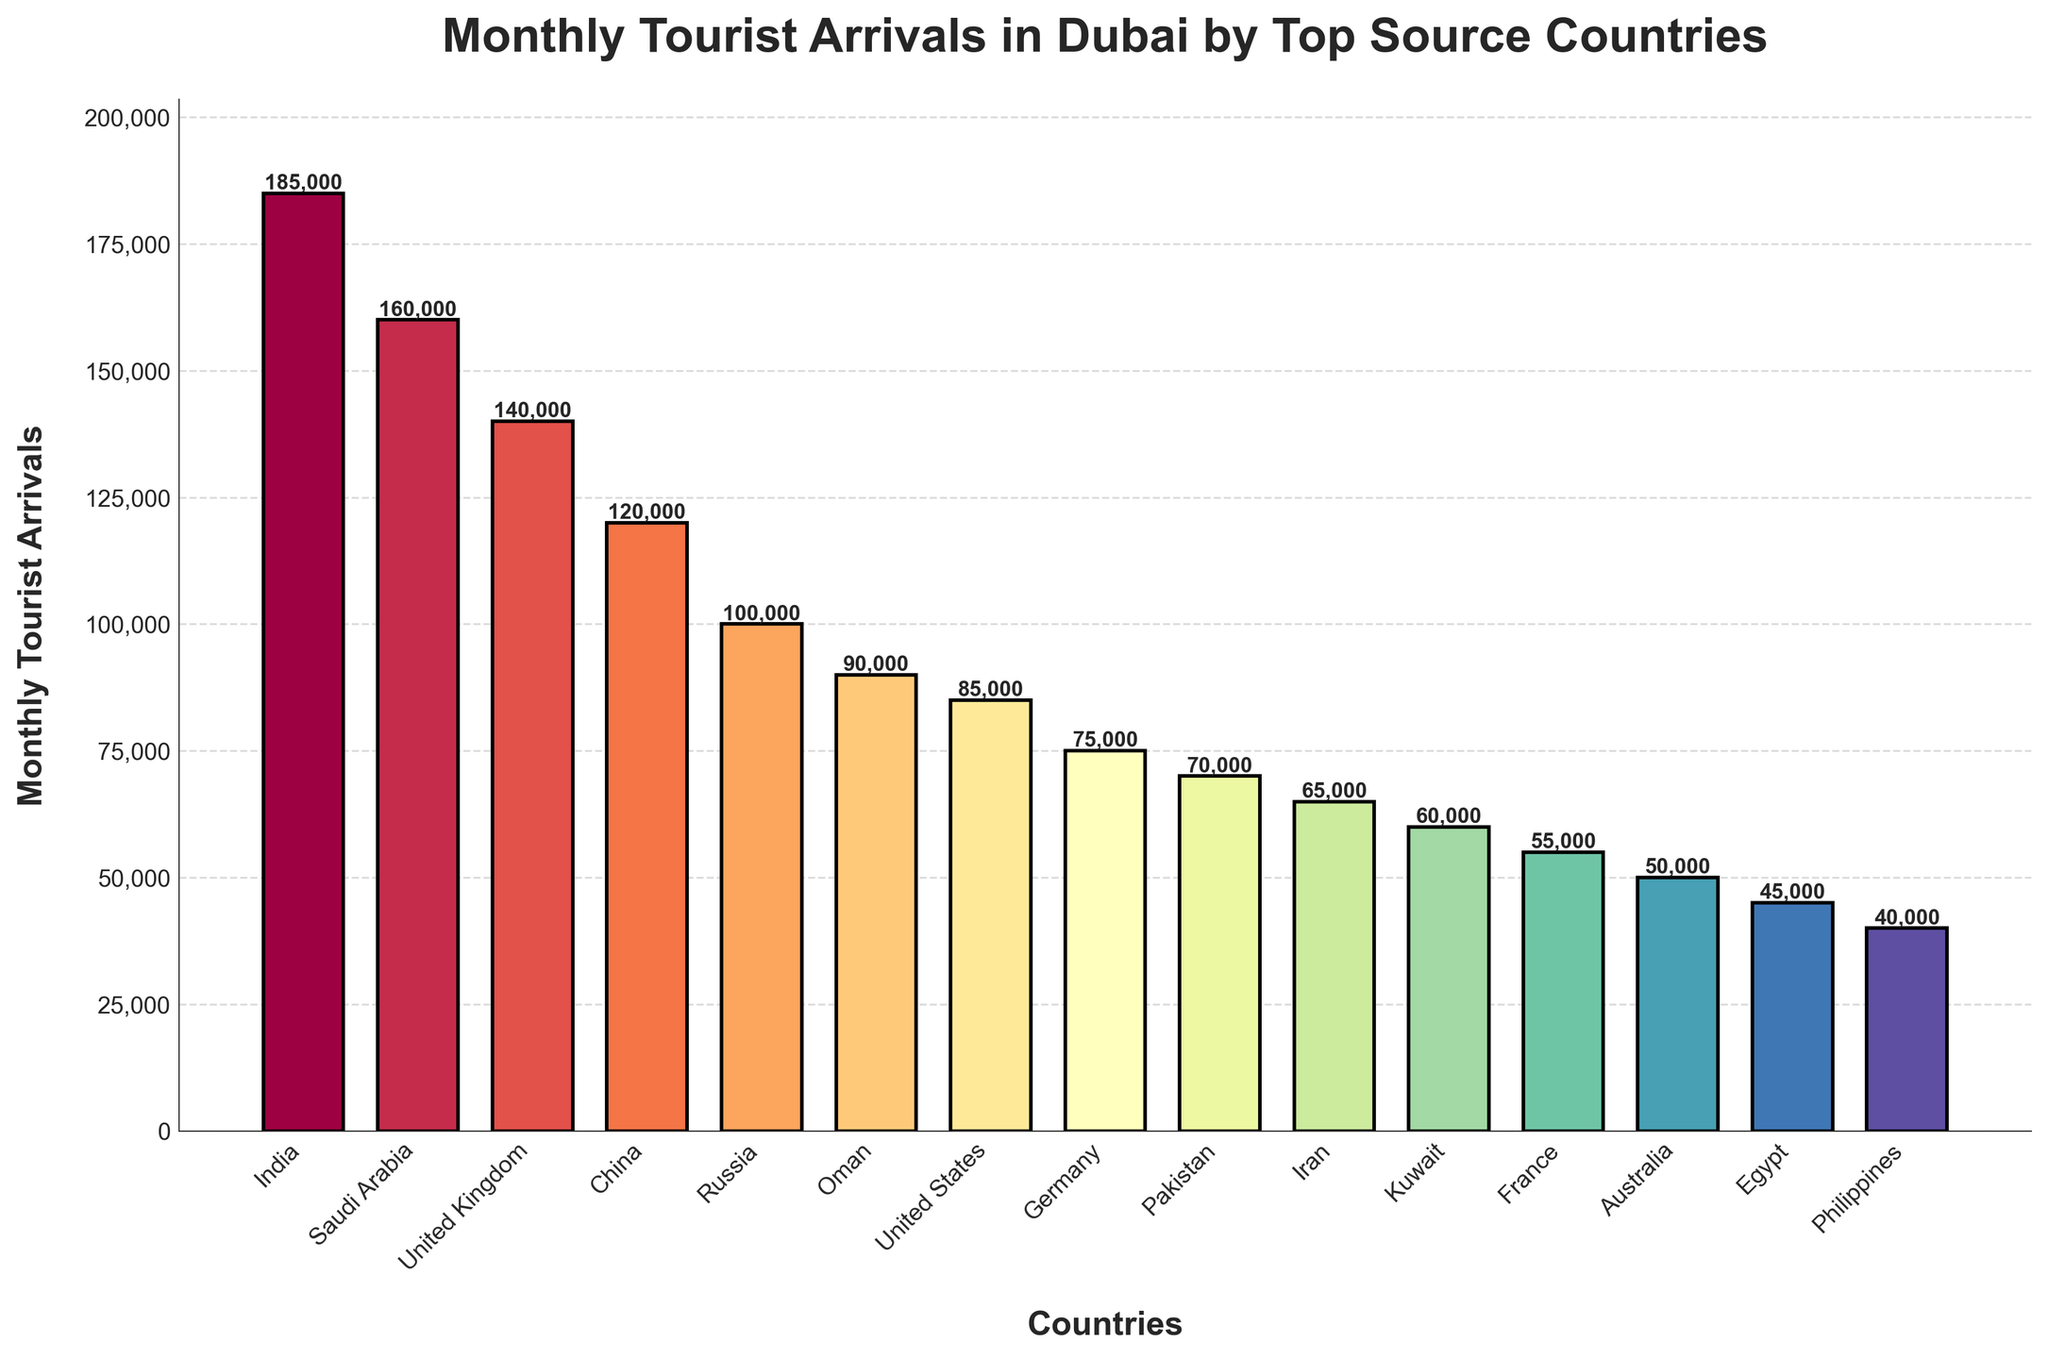Which country has the highest number of monthly tourist arrivals? The chart shows different bar heights representing monthly tourist arrivals from various countries. The tallest bar represents the country with the highest tourist arrivals. In this case, it is India.
Answer: India Which country has the lowest number of monthly tourist arrivals? By identifying the smallest bar in the chart, we can see that the country with the lowest tourist arrivals is the Philippines.
Answer: Philippines What is the total number of monthly tourist arrivals from Saudi Arabia and the United Kingdom? To find the total, add the number of arrivals from Saudi Arabia (160,000) and the United Kingdom (140,000). The calculation is 160,000 + 140,000 = 300,000.
Answer: 300,000 How many more monthly tourists does India have compared to the United States? First, find the number of tourist arrivals from India (185,000) and the United States (85,000). Then, subtract the United States' figure from India's: 185,000 - 85,000 = 100,000.
Answer: 100,000 What is the percentage of tourist arrivals from China over the total monthly tourist arrivals from the top five countries? First, calculate the total arrivals from the top five countries: India (185,000) + Saudi Arabia (160,000) + United Kingdom (140,000) + China (120,000) + Russia (100,000) = 705,000. Then, find the percentage of China's arrivals: (120,000 / 705,000) * 100 ≈ 17.02%.
Answer: 17.02% Which countries have monthly tourist arrivals between 50,000 and 100,000? By examining the heights of the bars, we identify the countries with tourist arrivals within this range: Russia (100,000), Oman (90,000), United States (85,000), Germany (75,000), Pakistan (70,000), and Iran (65,000).
Answer: Russia, Oman, United States, Germany, Pakistan, Iran What is the average number of monthly tourist arrivals for France, Australia, Egypt, and the Philippines? To find the average, first calculate the total: France (55,000) + Australia (50,000) + Egypt (45,000) + Philippines (40,000) = 190,000. Then, divide this number by the count of countries: 190,000 / 4 = 47,500.
Answer: 47,500 Which two adjacent countries, when combined, have the closest total monthly tourist arrivals to 250,000? We need to calculate combinations of adjacent countries. The closest ones are India (185,000) and Saudi Arabia (160,000). Adding them together: 185,000 + 160,000 = 345,000. However, the sum of Saudi Arabia (160,000) and the United Kingdom (140,000) is 300,000, which is closer.
Answer: Saudi Arabia and United Kingdom What is the difference in monthly tourist arrivals between Oman and Iran? Find the number of tourist arrivals from Oman (90,000) and Iran (65,000). Subtract Iran's arrivals from Oman's: 90,000 - 65,000 = 25,000.
Answer: 25,000 